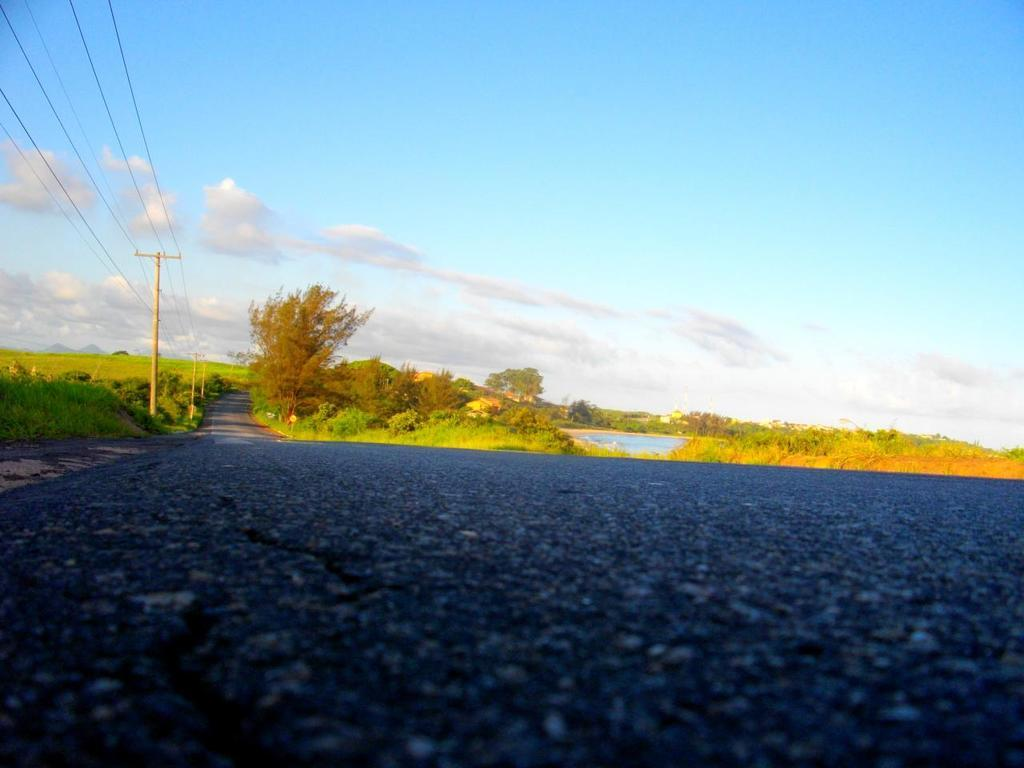What is the main feature of the image? There is a road in the image. What can be seen in the background of the image? In the background, there are poles, wires, trees, plants, water, and clouds in the sky. Can you describe the elements in the background in more detail? The poles and wires are likely related to power or communication infrastructure, while the trees and plants indicate a natural environment. The water and clouds suggest a possible landscape setting. How many dimes are scattered on the road in the image? There are no dimes visible on the road in the image. Can you describe the footwear of the person walking on the road in the image? There is no person walking on the road in the image. 